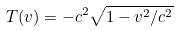Convert formula to latex. <formula><loc_0><loc_0><loc_500><loc_500>T ( { v } ) = - c ^ { 2 } \sqrt { 1 - { { v } ^ { 2 } } / { c ^ { 2 } } }</formula> 